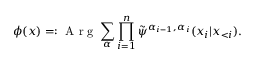<formula> <loc_0><loc_0><loc_500><loc_500>\phi ( x ) = \colon A r g \sum _ { \alpha } \prod _ { i = 1 } ^ { n } \tilde { \psi } ^ { \alpha _ { i - 1 } , \alpha _ { i } } ( x _ { i } | \boldsymbol x _ { < i } ) .</formula> 